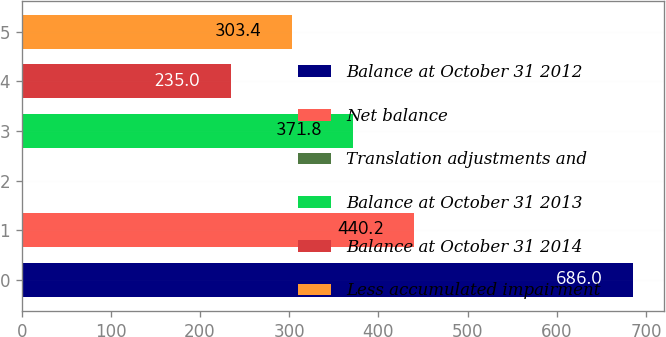<chart> <loc_0><loc_0><loc_500><loc_500><bar_chart><fcel>Balance at October 31 2012<fcel>Net balance<fcel>Translation adjustments and<fcel>Balance at October 31 2013<fcel>Balance at October 31 2014<fcel>Less accumulated impairment<nl><fcel>686<fcel>440.2<fcel>2<fcel>371.8<fcel>235<fcel>303.4<nl></chart> 